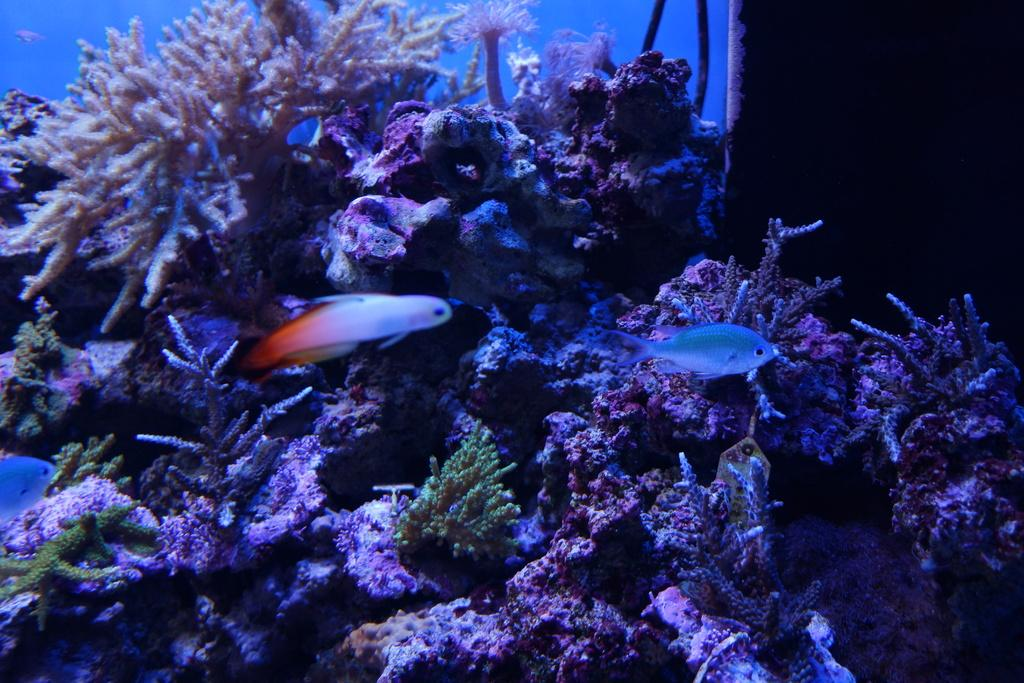What type of environment is shown in the image? The image depicts an underwater environment. What creatures can be seen in the underwater environment? Fish are swimming in the water. How many women are learning to ride a zephyr in the image? There are no women or zephyrs present in the image, as it depicts an underwater environment with fish swimming. 